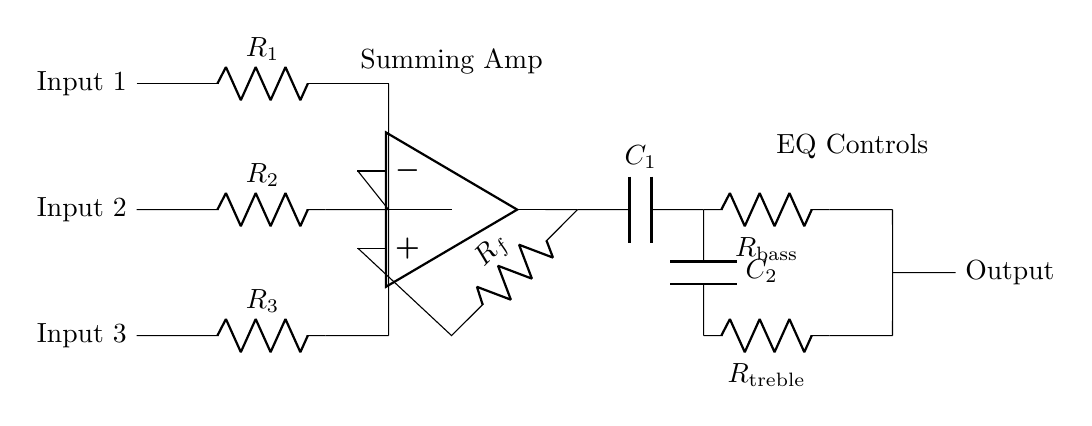What are the input channels in this mixer? The input channels are labeled as Input 1, Input 2, and Input 3 in the circuit diagram.
Answer: Input 1, Input 2, Input 3 What component serves as the summing amplifier? The summing amplifier is depicted as an operational amplifier in the circuit, which combines signals from the input resistors.
Answer: Operational amplifier How many resistors are used for equalization controls? There are two resistors used for equalization controls: one for bass and another for treble.
Answer: Two Which capacitors are used in the circuit? The circuit diagram includes two capacitors labeled as C1 and C2, appearing in connection with the equalization resistors.
Answer: C1, C2 What is the purpose of the feedback resistor in the summing amplifier? The feedback resistor, labeled as Rf, regulates the gain of the summing amplifier, determining how much of the output signal is fed back to the inverting input.
Answer: Regulates gain How does the output signal combine the input signals? The output signal is a linear combination of the input signals processed through the summing amplifier, reflecting the contributions from Input 1, Input 2, and Input 3.
Answer: Linear combination What kind of audio processing does this circuit facilitate? This circuit facilitates audio mixing and equalization, allowing multiple audio signals to be adjusted for bass and treble before output.
Answer: Mixing and equalization 